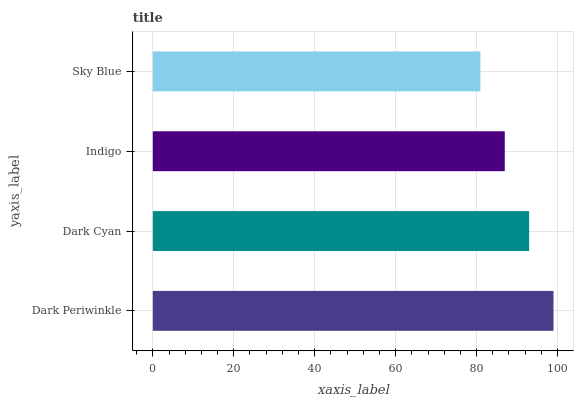Is Sky Blue the minimum?
Answer yes or no. Yes. Is Dark Periwinkle the maximum?
Answer yes or no. Yes. Is Dark Cyan the minimum?
Answer yes or no. No. Is Dark Cyan the maximum?
Answer yes or no. No. Is Dark Periwinkle greater than Dark Cyan?
Answer yes or no. Yes. Is Dark Cyan less than Dark Periwinkle?
Answer yes or no. Yes. Is Dark Cyan greater than Dark Periwinkle?
Answer yes or no. No. Is Dark Periwinkle less than Dark Cyan?
Answer yes or no. No. Is Dark Cyan the high median?
Answer yes or no. Yes. Is Indigo the low median?
Answer yes or no. Yes. Is Sky Blue the high median?
Answer yes or no. No. Is Dark Periwinkle the low median?
Answer yes or no. No. 